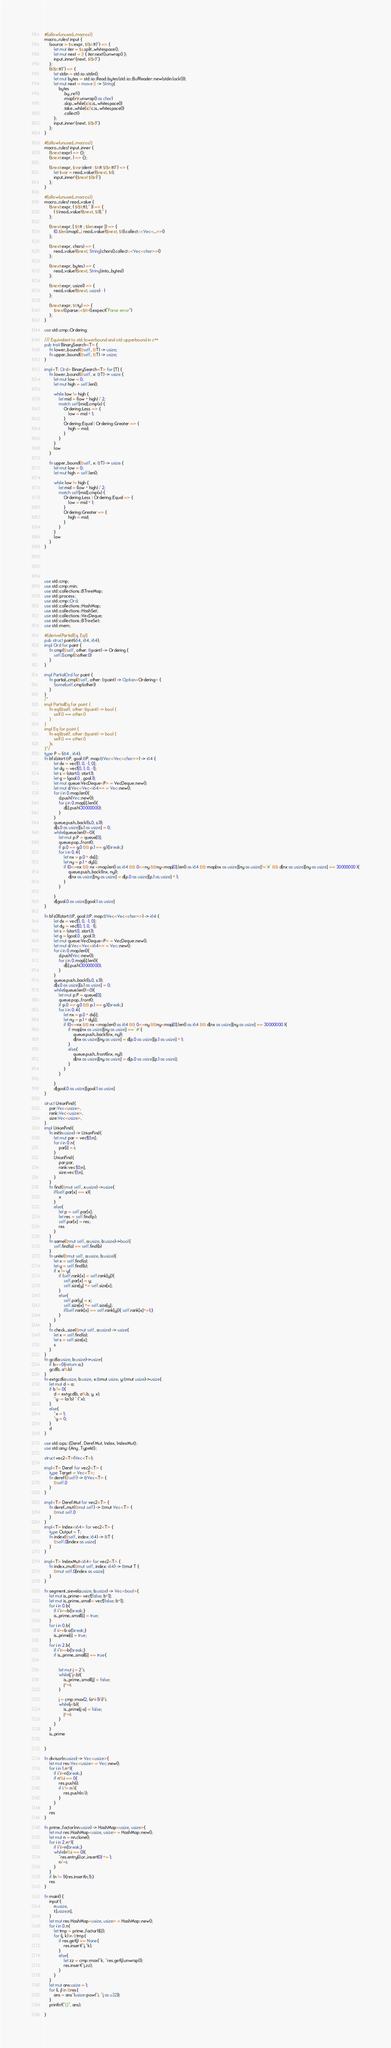<code> <loc_0><loc_0><loc_500><loc_500><_Rust_>#[allow(unused_macros)]
macro_rules! input {
    (source = $s:expr, $($r:tt)*) => {
        let mut iter = $s.split_whitespace();
        let mut next = || { iter.next().unwrap() };
        input_inner!{next, $($r)*}
    };
    ($($r:tt)*) => {
        let stdin = std::io::stdin();
        let mut bytes = std::io::Read::bytes(std::io::BufReader::new(stdin.lock()));
        let mut next = move || -> String{
            bytes
                .by_ref()
                .map(|r|r.unwrap() as char)
                .skip_while(|c|c.is_whitespace())
                .take_while(|c|!c.is_whitespace())
                .collect()
        };
        input_inner!{next, $($r)*}
    };
}
 
#[allow(unused_macros)]
macro_rules! input_inner {
    ($next:expr) => {};
    ($next:expr, ) => {};
 
    ($next:expr, $var:ident : $t:tt $($r:tt)*) => {
        let $var = read_value!($next, $t);
        input_inner!{$next $($r)*}
    };
}
 
#[allow(unused_macros)]
macro_rules! read_value {
    ($next:expr, ( $($t:tt),* )) => {
        ( $(read_value!($next, $t)),* )
    };
 
    ($next:expr, [ $t:tt ; $len:expr ]) => {
        (0..$len).map(|_| read_value!($next, $t)).collect::<Vec<_>>()
    };
 
    ($next:expr, chars) => {
        read_value!($next, String).chars().collect::<Vec<char>>()
    };
 
    ($next:expr, bytes) => {
        read_value!($next, String).into_bytes()
    };
 
    ($next:expr, usize1) => {
        read_value!($next, usize) - 1
    };
 
    ($next:expr, $t:ty) => {
        $next().parse::<$t>().expect("Parse error")
    };
}
 
use std::cmp::Ordering;
 
/// Equivalent to std::lowerbound and std::upperbound in c++
pub trait BinarySearch<T> {
    fn lower_bound(&self, &T) -> usize;
    fn upper_bound(&self, &T) -> usize;
}
 
impl<T: Ord> BinarySearch<T> for [T] {
    fn lower_bound(&self, x: &T) -> usize {
        let mut low = 0;
        let mut high = self.len();
 
        while low != high {
            let mid = (low + high) / 2;
            match self[mid].cmp(x) {
                Ordering::Less => {
                    low = mid + 1;
                }
                Ordering::Equal | Ordering::Greater => {
                    high = mid;
                }
            }
        }
        low
    }
 
    fn upper_bound(&self, x: &T) -> usize {
        let mut low = 0;
        let mut high = self.len();
 
        while low != high {
            let mid = (low + high) / 2;
            match self[mid].cmp(x) {
                Ordering::Less | Ordering::Equal => {
                    low = mid + 1;
                }
                Ordering::Greater => {
                    high = mid;
                }
            }
        }
        low
    }
}
 
 
 
 
 
 
use std::cmp;
use std::cmp::min;
use std::collections::BTreeMap;
use std::process;
use std::cmp::Ord;
use std::collections::HashMap;
use std::collections::HashSet;
use std::collections::VecDeque;
use std::collections::BTreeSet;
use std::mem;
 
#[derive(PartialEq, Eq)]
pub struct point(i64, i64, i64);
impl Ord for point {
    fn cmp(&self, other: &point) -> Ordering {
        self.0.cmp(&other.0)
    }
}
 
impl PartialOrd for point {
    fn partial_cmp(&self, other: &point) -> Option<Ordering> {
        Some(self.cmp(other))
    }
}
/*
impl PartialEq for point {
    fn eq(&self, other: &point) -> bool {
        self.0 == other.0
    }
}
impl Eq for point {
    fn eq(&self, other: &point) -> bool {
        self.0 == other.0
    }s
}*/
type P = (i64 , i64);
fn bfs(start:&P, goal:&P, map:&Vec<Vec<char>>) -> i64 {
        let dx = vec![1, 0, -1, 0];
        let dy = vec![0, 1, 0, -1];
        let s = (start.0, start.1);
        let g = (goal.0 , goal.1);
        let mut queue:VecDeque<P> = VecDeque::new();
        let mut d:Vec<Vec<i64>> = Vec::new();
        for i in 0..map.len(){
            d.push(Vec::new());
            for j in 0..map[i].len(){
                d[i].push(30000000);
            }
        }
        queue.push_back((s.0, s.1));
        d[s.0 as usize][s.1 as usize] = 0;
        while(queue.len()!=0){
            let mut p:P = queue[0];
            queue.pop_front();
            if p.0 == g.0 && p.1 == g.1{break;}
            for i in 0..4{
                let nx = p.0 + dx[i];
                let ny = p.1 + dy[i];
                if (0<=nx && nx <map.len() as i64 && 0<=ny &&ny<map[0].len() as i64 && map[nx as usize][ny as usize]!='#' && d[nx as usize][ny as usize] == 30000000 ){
                    queue.push_back((nx, ny));
                    d[nx as usize][ny as usize] = d[p.0 as usize][p.1 as usize] + 1;
                }
            }
 
        }
        d[goal.0 as usize][goal.1 as usize]
}
 
fn bfs01(start:&P, goal:&P, map:&Vec<Vec<char>>) -> i64 {
        let dx = vec![1, 0, -1, 0];
        let dy = vec![0, 1, 0, -1];
        let s = (start.0, start.1);
        let g = (goal.0 , goal.1);
        let mut queue:VecDeque<P> = VecDeque::new();
        let mut d:Vec<Vec<i64>> = Vec::new();
        for i in 0..map.len(){
            d.push(Vec::new());
            for j in 0..map[i].len(){
                d[i].push(30000000);
            }
        }
        queue.push_back((s.0, s.1));
        d[s.0 as usize][s.1 as usize] = 0;
        while(queue.len()!=0){
            let mut p:P = queue[0];
            queue.pop_front();
            if p.0 == g.0 && p.1 == g.1{break;}
            for i in 0..4{
                let nx = p.0 + dx[i];
                let ny = p.1 + dy[i];
                if (0<=nx && nx <map.len() as i64 && 0<=ny &&ny<map[0].len() as i64 && d[nx as usize][ny as usize] == 30000000 ){
                    if map[nx as usize][ny as usize] == '#'{
                        queue.push_back((nx, ny));
                        d[nx as usize][ny as usize] = d[p.0 as usize][p.1 as usize] + 1;
                    }
                    else{
                        queue.push_front((nx, ny));
                        d[nx as usize][ny as usize] = d[p.0 as usize][p.1 as usize];
                    }
                }
            }
 
        }
        d[goal.0 as usize][goal.1 as usize]
}
 
struct UnionFind{
    par:Vec<usize>,
    rank:Vec<usize>,
    size:Vec<usize>,    
}
impl UnionFind{
    fn init(n:usize) -> UnionFind{
        let mut par = vec![0;n];
        for i in 0..n{
            par[i] = i;    
        }
        UnionFind{
            par:par,
            rank:vec![0;n], 
            size:vec![1;n], 
        }
    }
    fn find(&mut self, x:usize) ->usize{
        if(self.par[x] == x){
            x    
        }
        else{
            let p = self.par[x];
            let res = self.find(p);
            self.par[x] = res;
            res
        }
    }
    fn same(&mut self, a:usize, b:usize)->bool{
        self.find(a) == self.find(b)    
    }
    fn unite(&mut self, a:usize, b:usize){
        let x = self.find(a);
        let y = self.find(b);
        if x != y{
            if (self.rank[x] < self.rank[y]){
                self.par[x] = y;
                self.size[y] += self.size[x];
            }
            else{
                self.par[y] = x;
                self.size[x] += self.size[y];
                if(self.rank[x] == self.rank[y]){ self.rank[x]+=1;}
            }
        }
    }
    fn check_size(&mut self, a:usize) -> usize{
        let x = self.find(a);
        let s = self.size[x];
        s    
    }
}
fn gcd(a:usize, b:usize)->usize{
    if b==0{return a;}
    gcd(b, a%b)
}
fn extgcd(a:usize, b:usize, x:&mut usize, y:&mut usize)->usize{
    let mut d = a;
    if b != 0{
        d = extgcd(b, a%b, y, x);
        *y -= (a/b) * (*x);    
    }    
    else{
        *x = 1;
        *y = 0;
    }
    d
}

use std::ops::{Deref, DerefMut, Index, IndexMut};
use std::any::{Any, TypeId};

struct vec2<T>(Vec<T>);
 
impl<T> Deref for vec2<T> {
    type Target = Vec<T>;
    fn deref(&self) -> &Vec<T> {
        &self.0
    }
}
 
impl<T> DerefMut for vec2<T> {
    fn deref_mut(&mut self) -> &mut Vec<T> {
        &mut self.0
    }
}
impl<T> Index<i64> for vec2<T> {
    type Output = T;
    fn index(&self, index: i64) -> &T {
        &self.0[index as usize]
    }
}
 
impl<T> IndexMut<i64> for vec2<T> {
    fn index_mut(&mut self, index: i64) -> &mut T {
        &mut self.0[index as usize]
    }
}

fn segment_sieve(a:usize, b:usize) -> Vec<bool>{
    let mut is_prime= vec![false; b+1];
    let mut is_prime_small= vec![false; b+1];
    for i in 0..b{
        if i*i>=b{break;}    
        is_prime_small[i] = true;
    }
    for i in 0..b{
        if i>=b-a{break;}
        is_prime[i] = true;    
    }
    for i in 2..b{
        if i*i>=b{break;}
        if is_prime_small[i] == true{


            let mut j = 2*i;
            while(j*j<b){
                is_prime_small[j] = false;
                j+=i;
            }
            
            j = cmp::max(2, (a+i-1)/i)*i;
            while(j<b){
                is_prime[j-a] = false;
                j+=i;    
            }    
        }    
    }
    is_prime


}

fn divisor(n:usize) -> Vec<usize>{
    let mut res:Vec<usize> = Vec::new(); 
    for i in 1..n+1{
        if i*i>n{break;}
        if n%i == 0{
            res.push(i);
            if i != n/i{
                res.push(n/i);    
            }    
        }    
    }
    res
}

fn prime_factor(nn:usize) -> HashMap<usize, usize>{
    let mut res:HashMap<usize, usize> = HashMap::new();
    let mut n = nn.clone();
    for i in 2..n+1{
        if i*i>n{break;}
        while(n%i == 0){
            *res.entry(i).or_insert(0) += 1;
            n/=i;    
        }    
    }
    if (n != 1){res.insert(n,1);}
    res
}

fn main() {
    input!{
        n:usize,
        t:[usize;n],
    }
    let mut res:HashMap<usize, usize> = HashMap::new();
    for i in 0..n{
        let tmp = prime_factor(t[i]);
        for (j, k) in &tmp{
            if res.get(j) == None{
                res.insert(*j,*k);    
            }   
            else{
                let zz = cmp::max(*k, *res.get(j).unwrap());
                res.insert(*j,zz);    
            }
        }
    }
    let mut ans:usize = 1;
    for (i, j) in &res{
        ans = ans*(usize::pow(*i, *j as u32));
    }
    println!("{}", ans);

}

</code> 